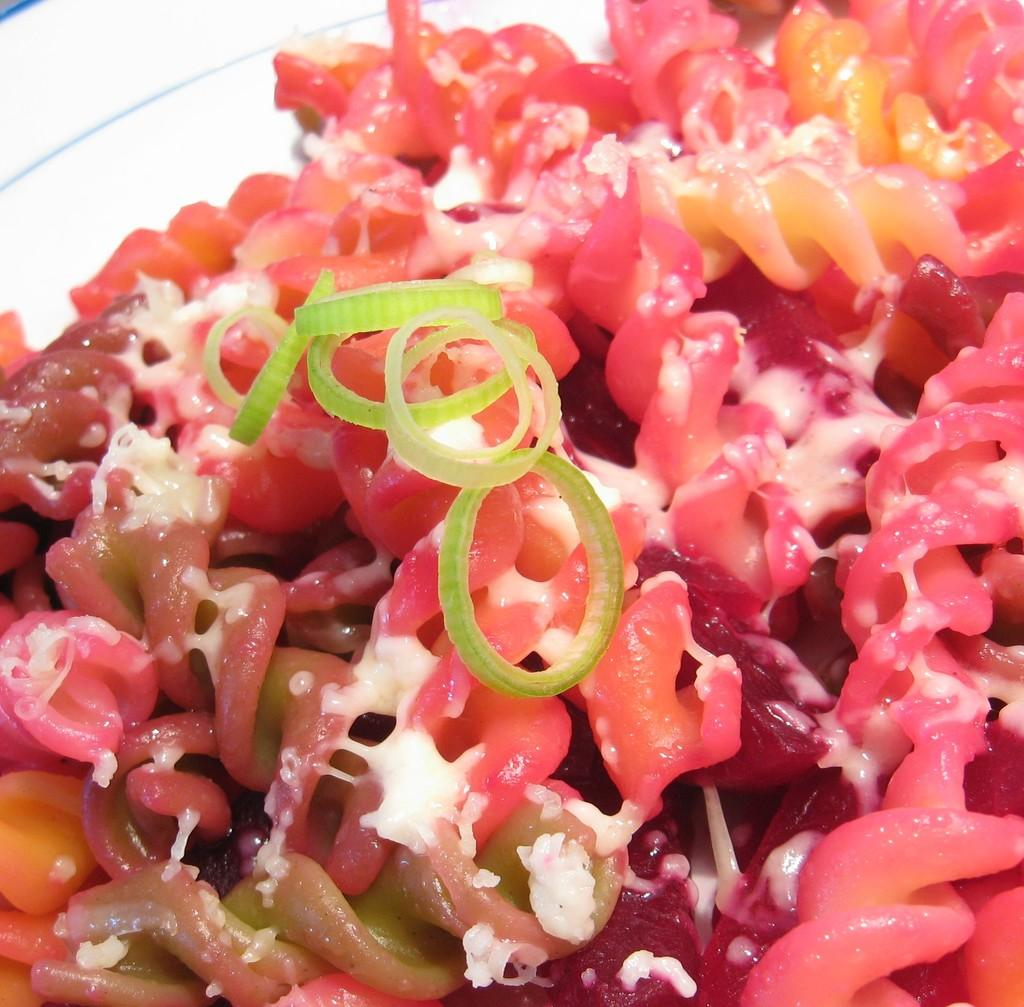What color is the plate that is visible in the image? The plate in the image is white. What is located above the white plate? There is food above the white plate. What is the title of the book that is being read by the person in the image? There is no person or book present in the image; it only features a white plate and food above it. 